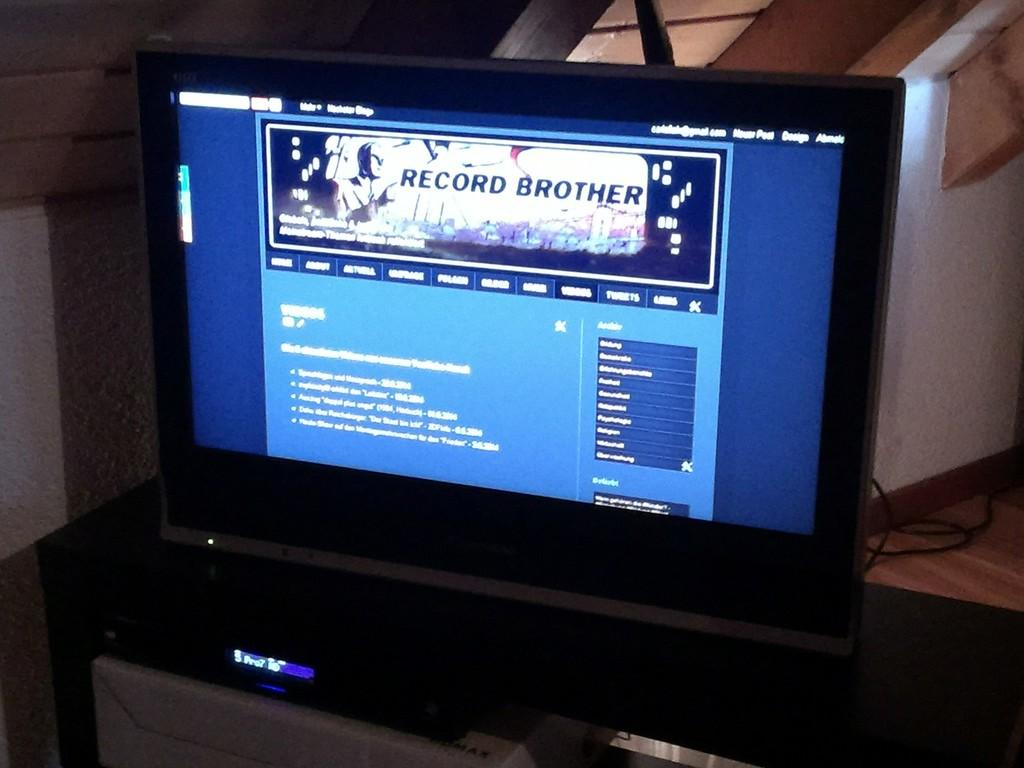<image>
Present a compact description of the photo's key features. The tv is displaying a picture at the top that says Record Brother. 